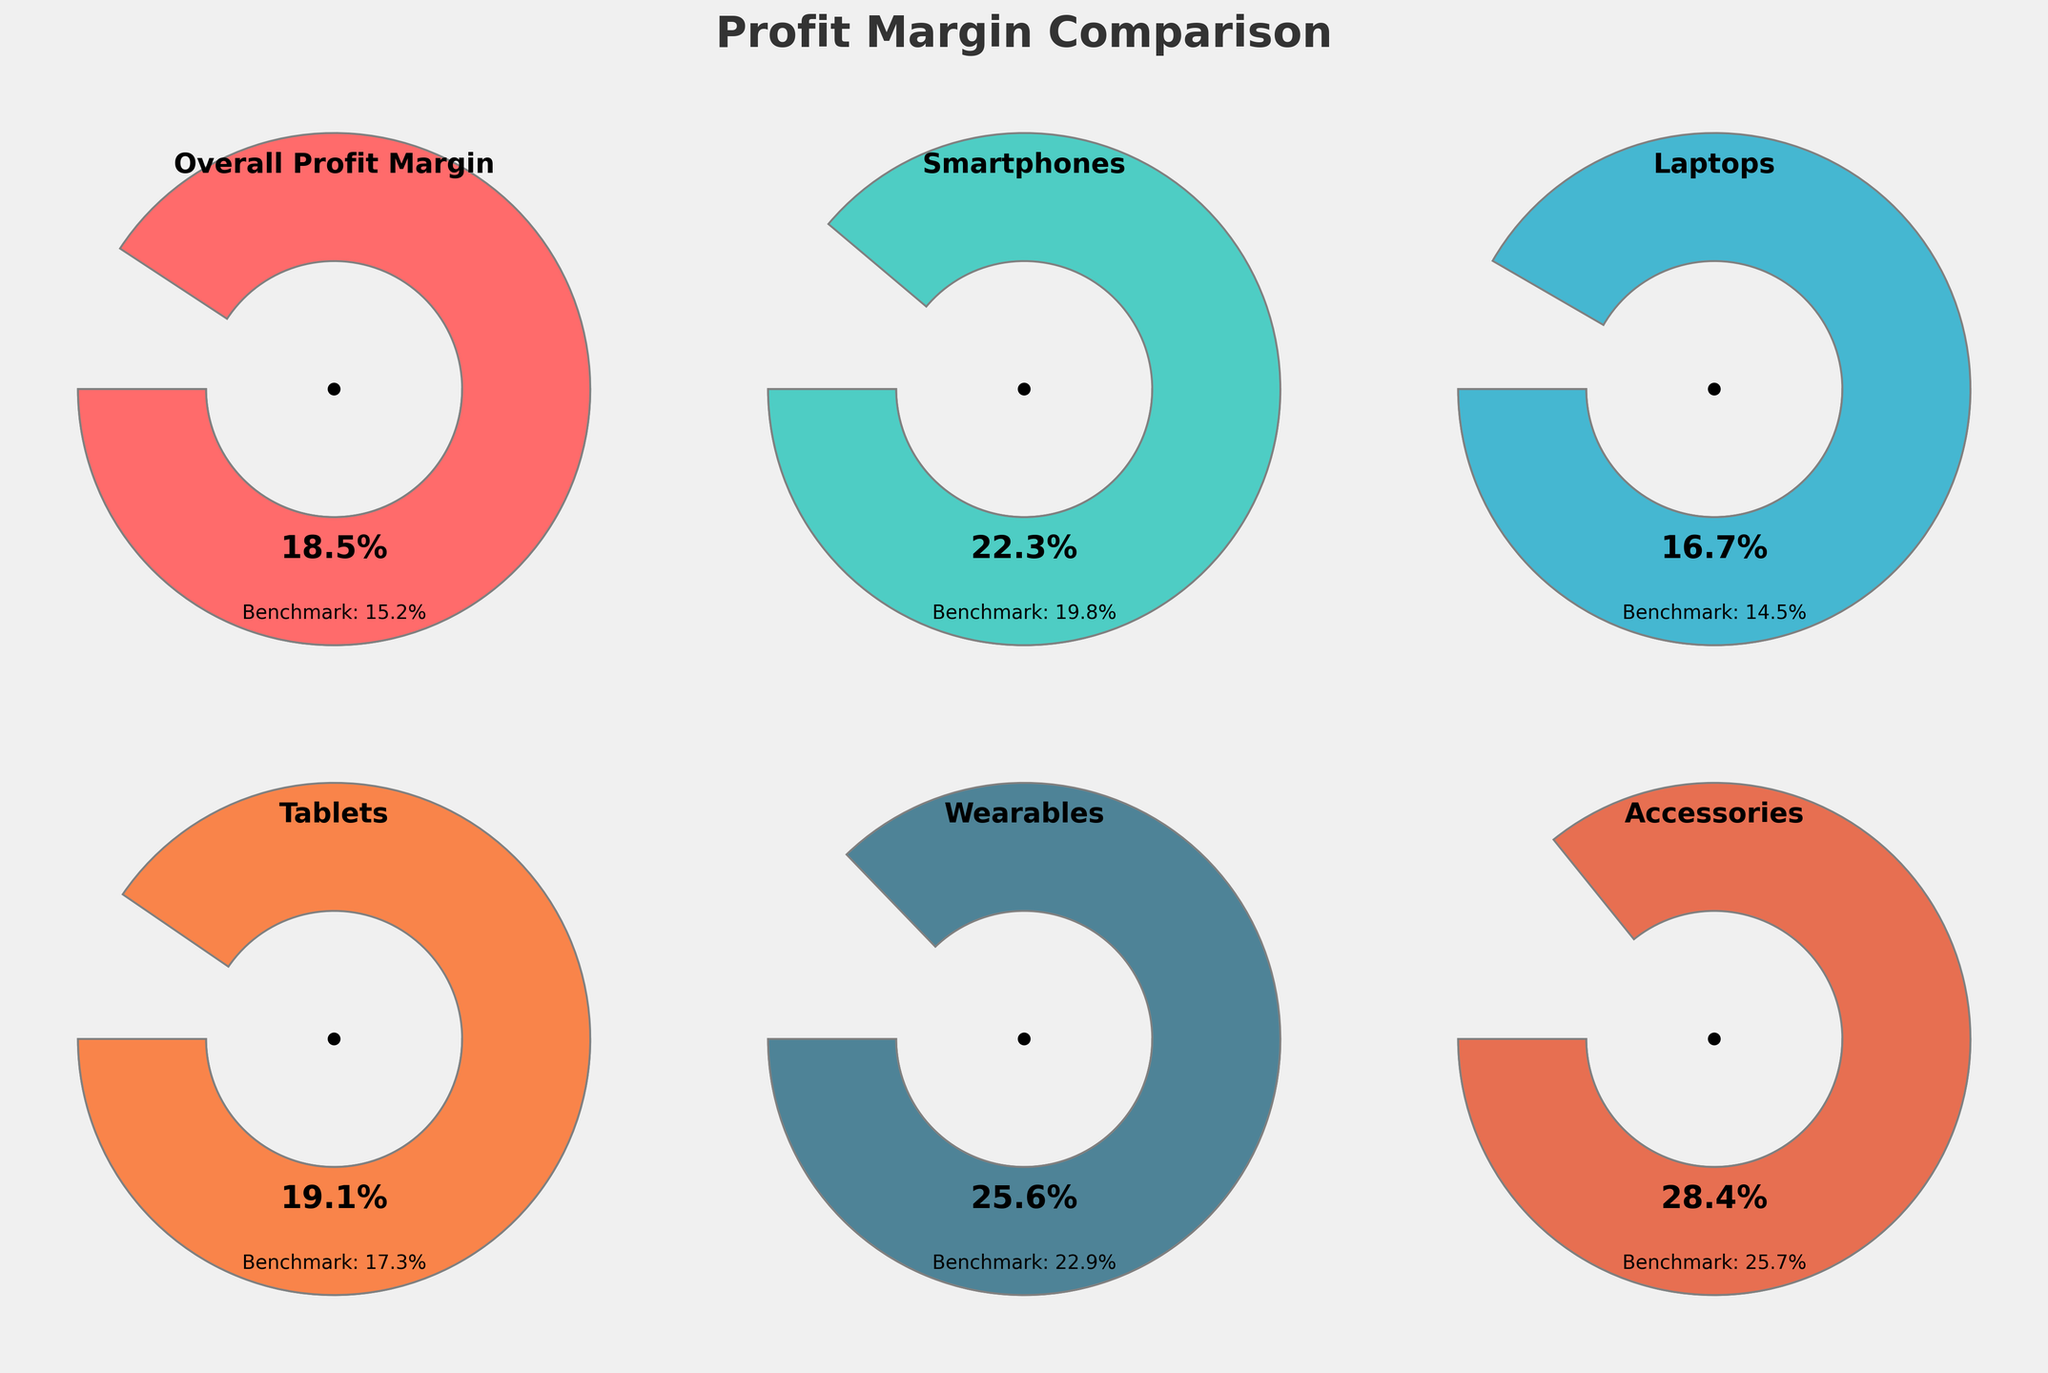What is the title of the figure? The title is typically found at the top of the chart and is designed to give an overview of what the entire figure represents
Answer: Profit Margin Comparison How does your business's overall profit margin compare to the industry benchmark? By looking at the gauge for "Overall Profit Margin", your business has a profit margin of 18.5%, while the industry benchmark is 15.2%
Answer: 18.5% vs 15.2% Which category has the highest profit margin for both your business and the industry benchmark? By scanning through all gauges, the highest profit margin for your business is in the 'Accessories' category with 28.4%, and for the industry benchmark, it's also 'Accessories' with 25.7%
Answer: Accessories Which category shows the smallest difference between your business and the industry benchmark profit margins? By calculating the differences for each: (22.3-19.8)=2.5, (16.7-14.5)=2.2, (19.1-17.3)=1.8, (25.6-22.9)=2.7, (28.4-25.7)=2.7. The smallest difference is in 'Tablets' with 1.8
Answer: Tablets What is the average profit margin of your business across all categories? Add all margins and divide by the number: (18.5 + 22.3 + 16.7 + 19.1 + 25.6 + 28.4) / 6
Answer: 21.77% By how much does your business's profit margin in 'Smartphones' exceed the industry benchmark? By subtracting, (22.3 - 19.8)
Answer: 2.5% Which category in your business has a profit margin closest to 20%? Reviewing all values, compare each to 20%: 18.5, 22.3, 16.7, 19.1, 25.6, 28.4. The closest is 'Tablets' with 19.1%
Answer: Tablets In which category is the difference between your business's profit margin and the industry benchmark the largest? Calculating the differences: (22.3-19.8)=2.5, (16.7-14.5)=2.2, (19.1-17.3)=1.8, (25.6-22.9)=2.7, (28.4-25.7)=2.7. The largest difference occurs in 'Access. & Wear.' with 2.7
Answer: Accessories and Wearables Do all categories show a higher profit margin for your business compared to the industry benchmark? Yes, each gauge shows your business's values are higher than the benchmarks when comparing each pair
Answer: Yes 